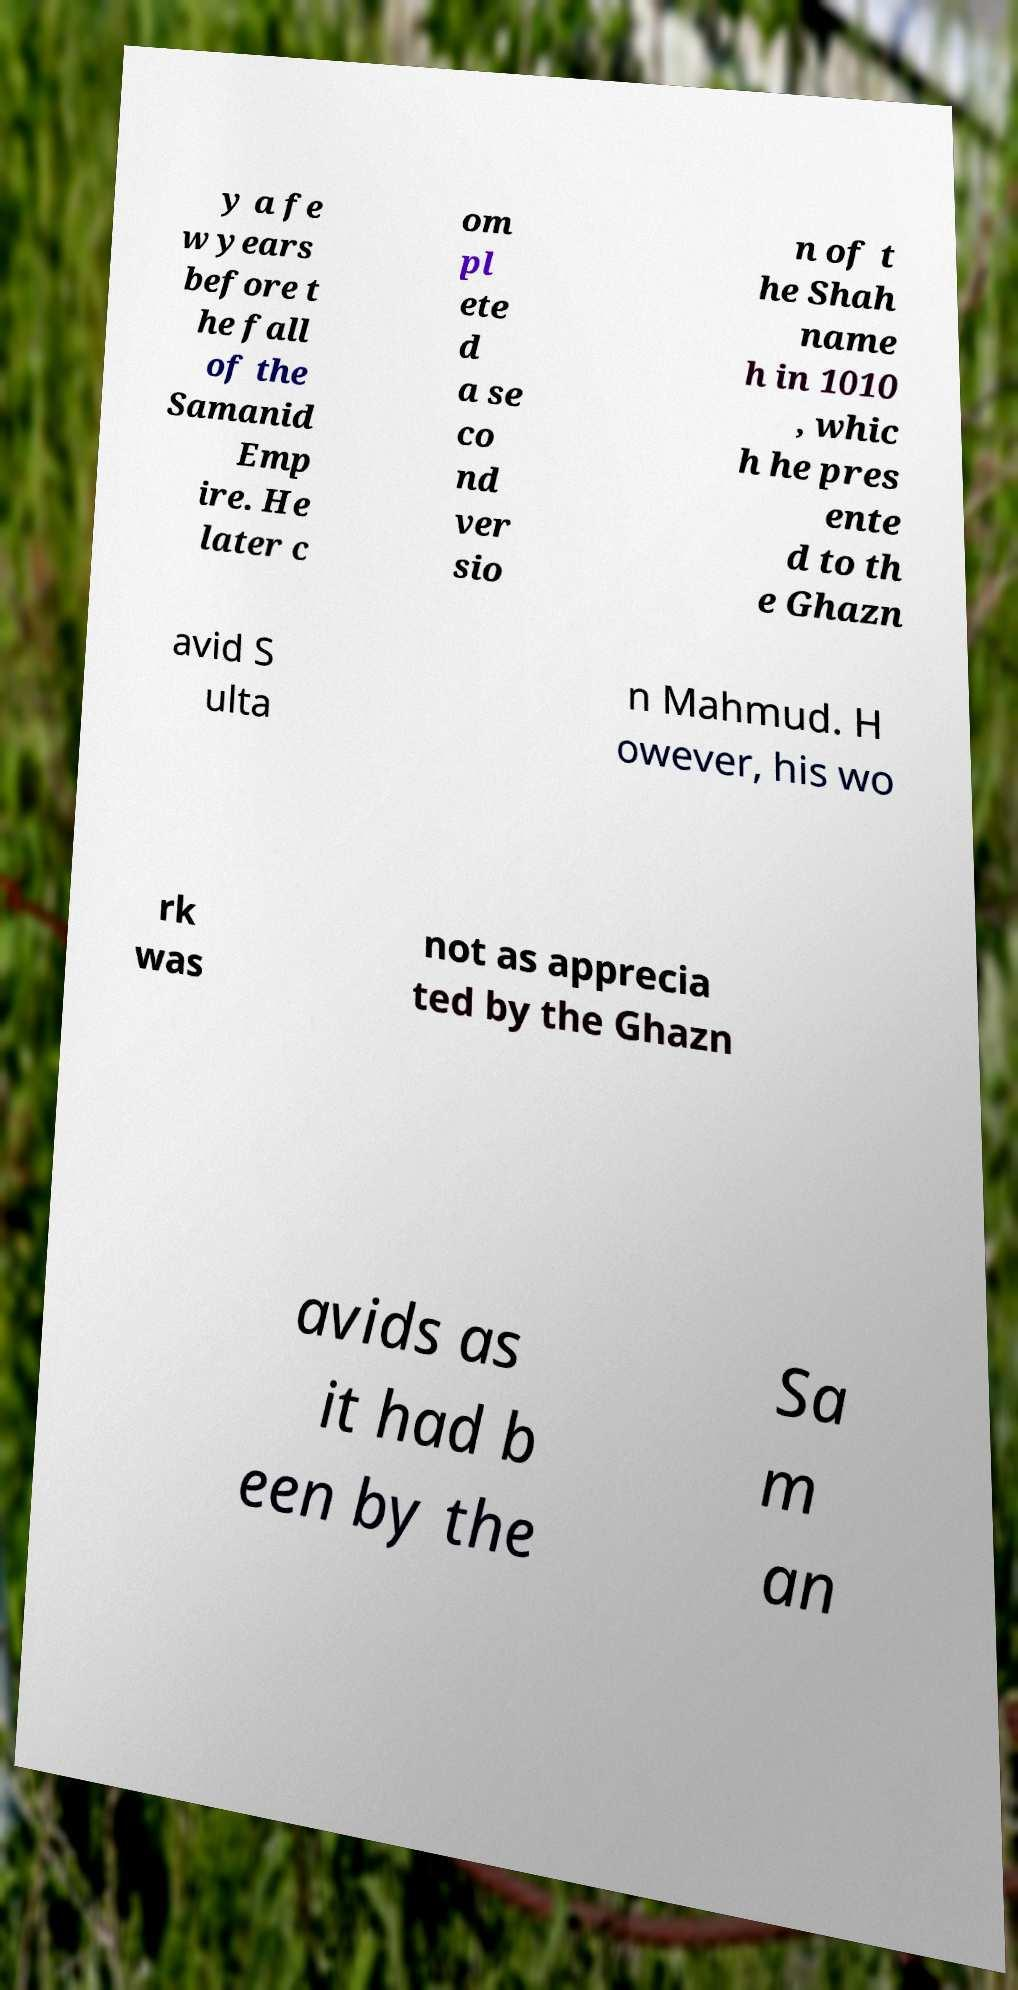Please identify and transcribe the text found in this image. y a fe w years before t he fall of the Samanid Emp ire. He later c om pl ete d a se co nd ver sio n of t he Shah name h in 1010 , whic h he pres ente d to th e Ghazn avid S ulta n Mahmud. H owever, his wo rk was not as apprecia ted by the Ghazn avids as it had b een by the Sa m an 